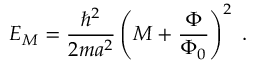Convert formula to latex. <formula><loc_0><loc_0><loc_500><loc_500>E _ { M } = \frac { \hbar { ^ } { 2 } } { 2 m a ^ { 2 } } \left ( M + \frac { \Phi } { \Phi _ { 0 } } \right ) ^ { 2 } \, .</formula> 